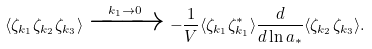Convert formula to latex. <formula><loc_0><loc_0><loc_500><loc_500>\langle \zeta _ { { k } _ { 1 } } \zeta _ { { k } _ { 2 } } \zeta _ { { k } _ { 3 } } \rangle \xrightarrow { k _ { 1 } \rightarrow 0 } - \frac { 1 } { V } \langle \zeta _ { { k } _ { 1 } } \zeta _ { { k } _ { 1 } } ^ { * } \rangle \frac { d } { d \ln a _ { * } } \langle \zeta _ { { k } _ { 2 } } \zeta _ { { k } _ { 3 } } \rangle .</formula> 